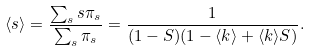Convert formula to latex. <formula><loc_0><loc_0><loc_500><loc_500>\langle s \rangle = \frac { \sum _ { s } s \pi _ { s } } { \sum _ { s } \pi _ { s } } = \frac { 1 } { ( 1 - S ) ( 1 - \langle k \rangle + \langle k \rangle S ) } .</formula> 